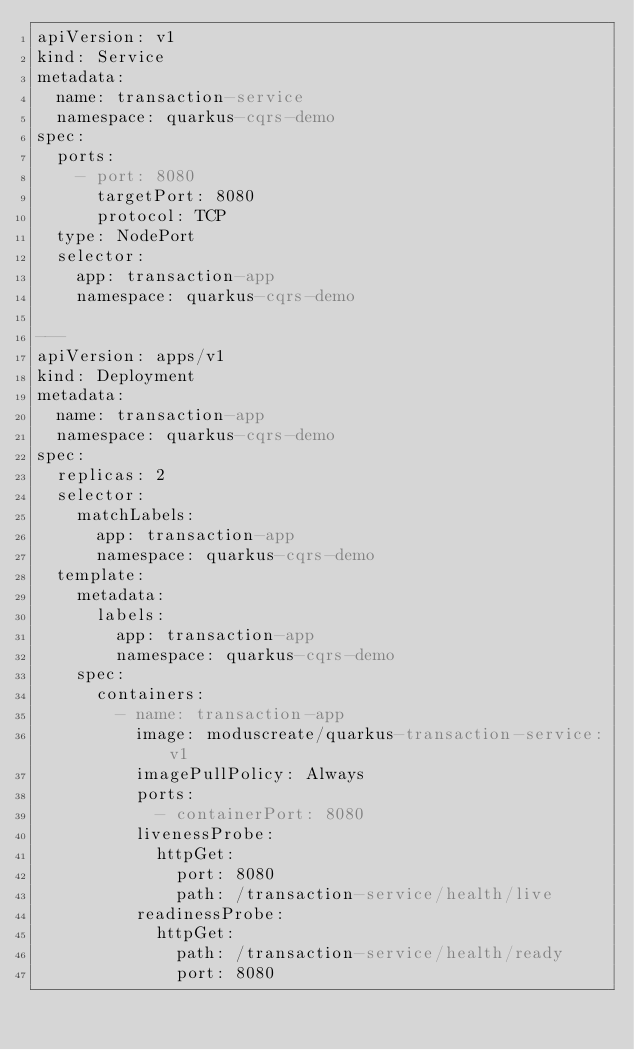<code> <loc_0><loc_0><loc_500><loc_500><_YAML_>apiVersion: v1
kind: Service
metadata:
  name: transaction-service
  namespace: quarkus-cqrs-demo
spec:
  ports:
    - port: 8080
      targetPort: 8080
      protocol: TCP
  type: NodePort
  selector:
    app: transaction-app
    namespace: quarkus-cqrs-demo

---
apiVersion: apps/v1
kind: Deployment
metadata:
  name: transaction-app
  namespace: quarkus-cqrs-demo
spec:
  replicas: 2
  selector:
    matchLabels:
      app: transaction-app
      namespace: quarkus-cqrs-demo
  template:
    metadata:
      labels:
        app: transaction-app
        namespace: quarkus-cqrs-demo
    spec:
      containers:
        - name: transaction-app
          image: moduscreate/quarkus-transaction-service:v1
          imagePullPolicy: Always
          ports:
            - containerPort: 8080
          livenessProbe:
            httpGet:
              port: 8080
              path: /transaction-service/health/live
          readinessProbe:
            httpGet:
              path: /transaction-service/health/ready
              port: 8080</code> 